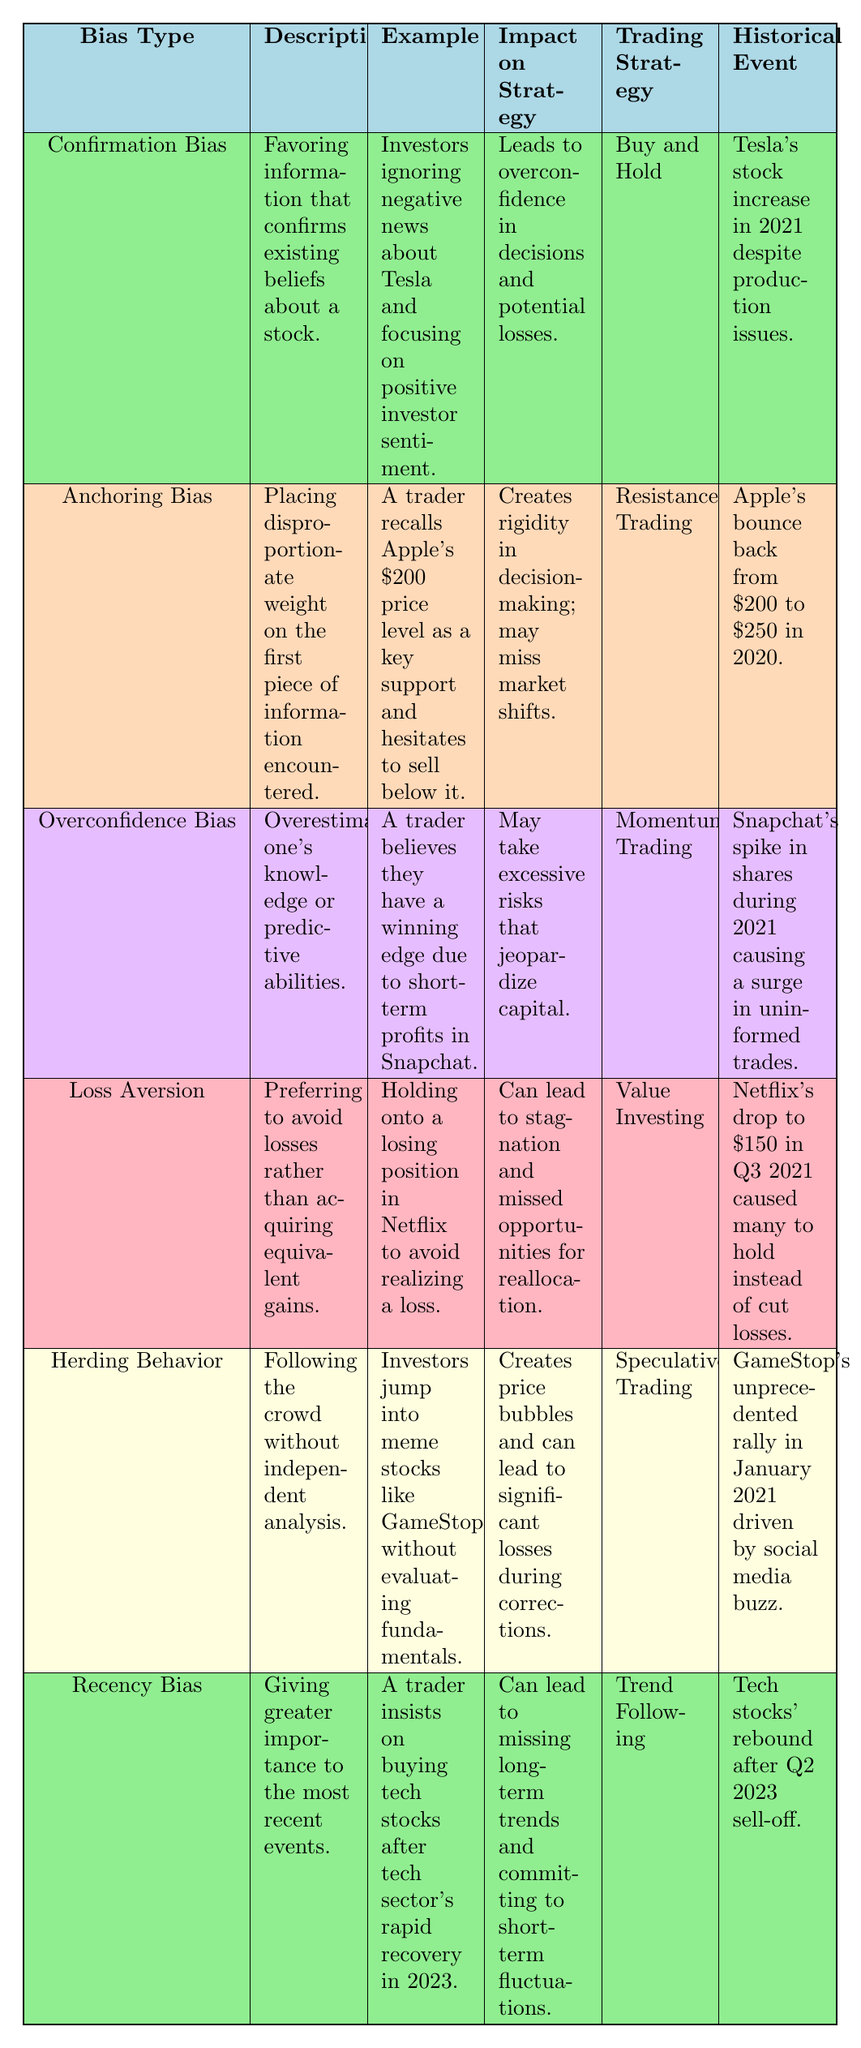What is the bias type associated with the psychological tendency to avoid realizing losses? The table specifies that "Loss Aversion" is the bias type that refers to preferring to avoid losses rather than acquiring equivalent gains.
Answer: Loss Aversion Which trading strategy is linked to Confirmation Bias? According to the table, "Buy and Hold" is listed as the trading strategy associated with Confirmation Bias.
Answer: Buy and Hold What notable historical event is mentioned for Herding Behavior? The table specifies that the unprecedented rally of GameStop in January 2021, driven by social media buzz, is the related historical event for Herding Behavior.
Answer: GameStop's unprecedented rally in January 2021 Are traders susceptible to Overconfidence Bias more likely to take excessive risks? The impact on strategy from the Overconfidence Bias is described as taking excessive risks that jeopardize capital, indicating that traders with this bias too often take such risks.
Answer: Yes What is the trading strategy employed when facing Recency Bias? The described trading strategy for Recency Bias in the table is "Trend Following." This implies that traders are likely buying based on short-term market movements.
Answer: Trend Following How many biases listed favor the 'Buy and Hold' strategy? The table indicates that only one bias, Confirmation Bias, supports the 'Buy and Hold' strategy, while the other five biases correlate with different strategies.
Answer: 1 What is the example provided for Anchoring Bias? The table shows that an example of Anchoring Bias is when a trader recalls Apple's $200 price level as a key support and hesitates to sell below it.
Answer: A trader recalls Apple's $200 price level Does Loss Aversion lead to active trading strategies? The explanation for Loss Aversion in the table mentions that it can lead to stagnation and missed opportunities for reallocation, which implies a tendency to hold rather than actively trade.
Answer: No Which bias is characterized by following the crowd without independent analysis? As per the table, Herding Behavior is described as the bias that involves following the crowd without conducting independent analysis.
Answer: Herding Behavior What is the impact on strategy due to Recency Bias? The table indicates that Recency Bias can lead to missing long-term trends and committing to short-term fluctuations, thereby affecting decision-making negatively.
Answer: Missing long-term trends 